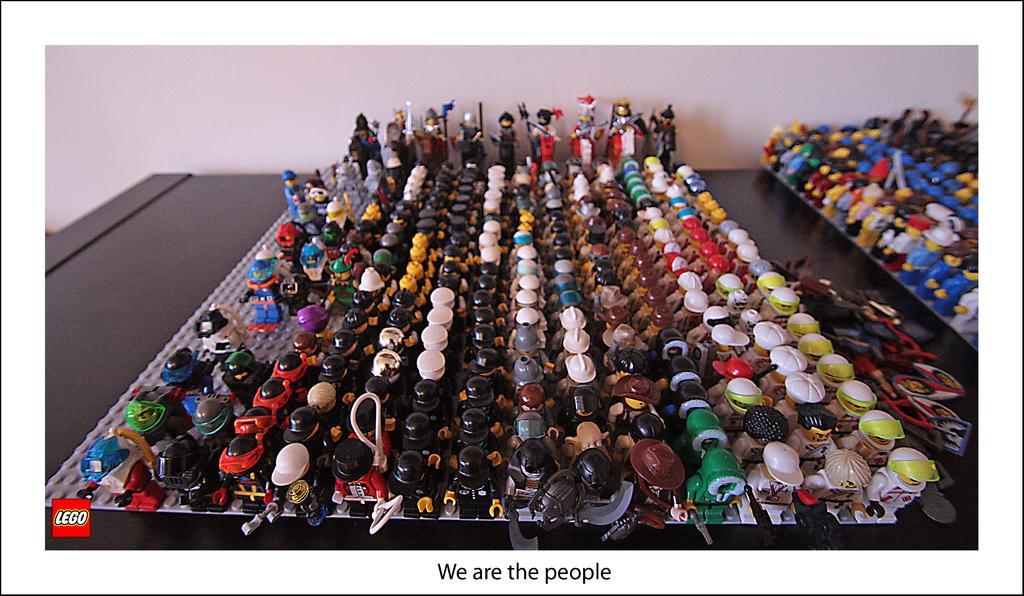Could you give a brief overview of what you see in this image? This image consists of small dolls and puppets kept on the desk. The desk is in black color. In the background, we can see a wall. 